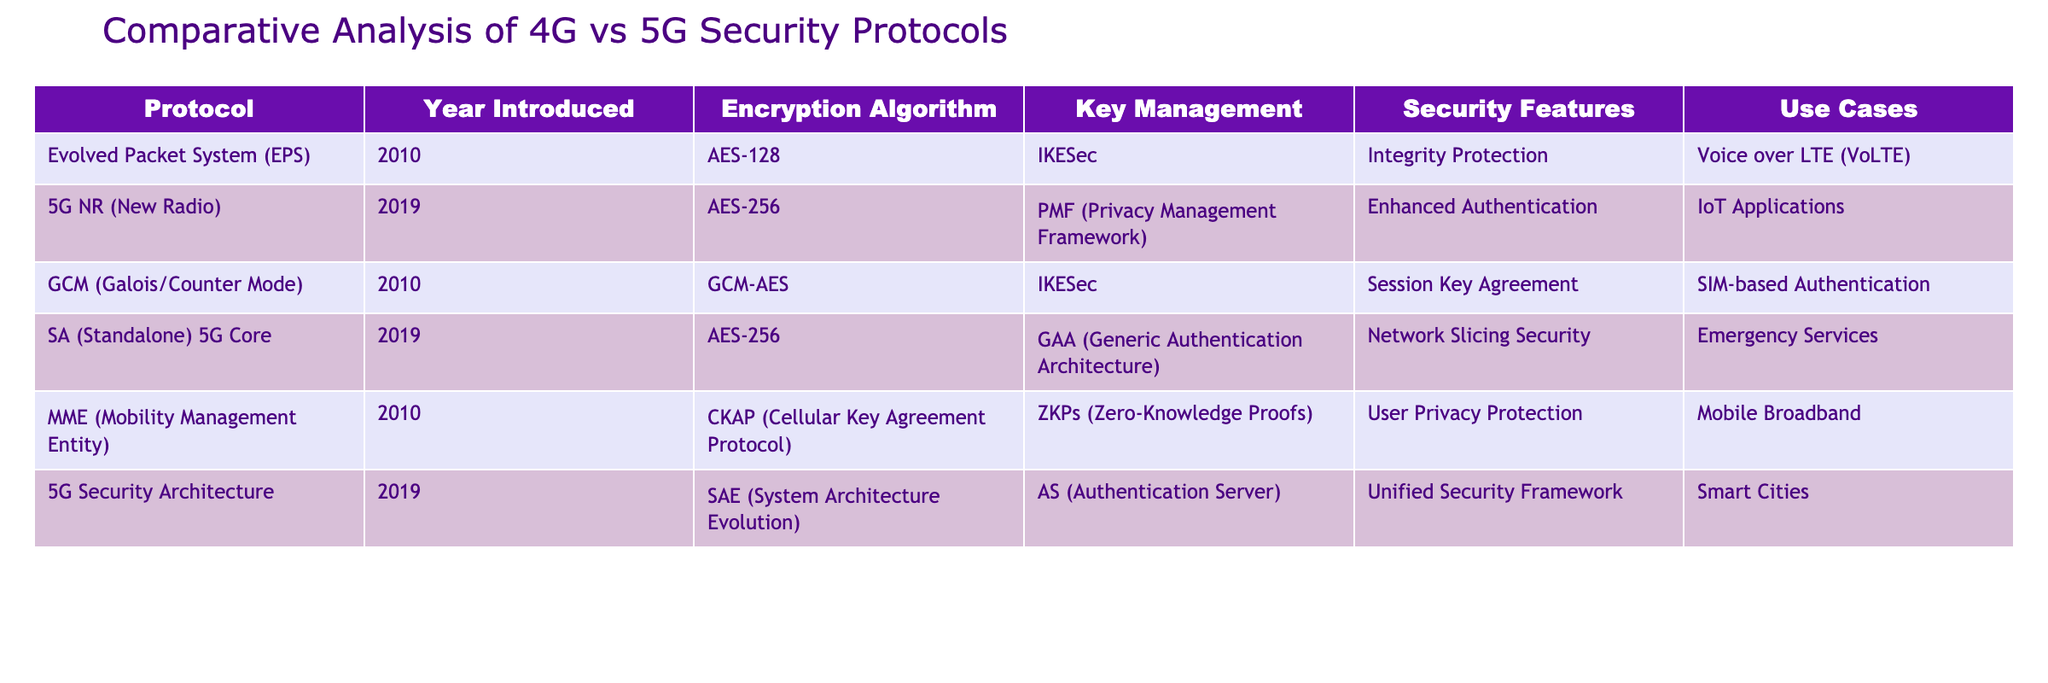What year was the Evolved Packet System introduced? The table lists the year introduced for each protocol. Looking at the row for the Evolved Packet System, it shows the year as 2010.
Answer: 2010 Which encryption algorithm is used by 5G NR? The table provides information on the encryption algorithm for each protocol. For the 5G NR row, the encryption algorithm is listed as AES-256.
Answer: AES-256 What are the unique security features of the SA 5G Core? By checking the SA 5G Core row in the table, the unique security features mentioned are Network Slicing Security.
Answer: Network Slicing Security Do both 4G and 5G protocols use AES encryption? The table indicates that the Evolved Packet System utilizes AES-128 and 5G NR uses AES-256. Hence, both 4G and 5G protocols employ AES encryption.
Answer: Yes How many protocols introduced in 2010 have key management systems listed? From the table, the protocols introduced in 2010 are Evolved Packet System, GCM, and MME. Each protocol has a key management system listed (IKESec for EPS and GCM, CKAP for MME), resulting in a total of 3 protocols with key management systems.
Answer: 3 What is the difference in the encryption algorithms between 4G and 5G protocols? Looking at the encryption algorithms in the table, 4G protocols (EPS, GCM, MME) use AES-128 and other specific algorithms, while 5G protocols (5G NR and SA 5G Core) use AES-256. Therefore, the difference is that 5G uses a more secure AES variant.
Answer: 5G uses AES-256, while 4G uses AES-128 Are the same use cases applied in 4G and 5G protocols? By analyzing the use cases in the table, we see that VoLTE and Mobile Broadband are specific to 4G, whereas IoT Applications, Emergency Services, and Smart Cities are specified for 5G protocols. Therefore, they have different use cases and are not the same.
Answer: No Which protocol has enhanced authentication as a security feature? In the table, the 5G NR row lists Enhanced Authentication as a security feature.
Answer: 5G NR 